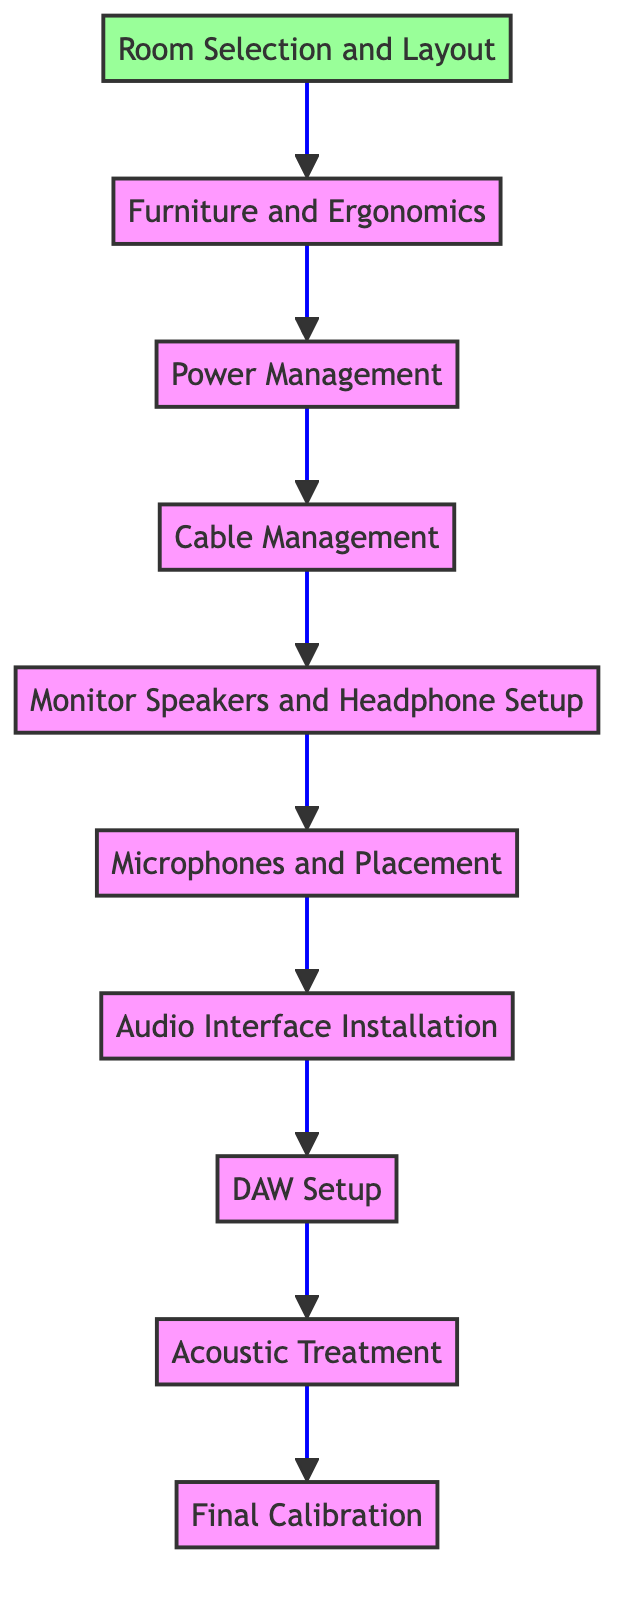What is the first step in setting up a home recording studio? The diagram indicates that the first step is "Room Selection and Layout," which is positioned at the bottom of the flow chart.
Answer: Room Selection and Layout How many nodes are in the flow chart? Counting all the elements listed in the diagram reveals there are ten nodes representing various steps in the home recording studio setup process.
Answer: Ten What follows the "Power Management" step? In the flow chart, "Cable Management" immediately follows "Power Management," indicating that it is the next step after addressing power concerns.
Answer: Cable Management Which step is directly above "Final Calibration"? The step directly above "Final Calibration" in the diagram is "Acoustic Treatment," showing the order of operations in setting up the studio.
Answer: Acoustic Treatment What is the last step in the process? The final step at the top of the flow chart is "Final Calibration," which indicates the concluding task in setting up the home recording studio.
Answer: Final Calibration How many steps are between "Monitor Speakers and Headphone Setup" and "DAW Setup"? There is one step in between "Monitor Speakers and Headphone Setup" and "DAW Setup," which is "Audio Interface Installation."
Answer: One What type of equipment is mentioned in the "Microphones and Placement" step? The step "Microphones and Placement" discusses selecting and positioning specific microphones, such as the Shure SM7B or Neumann U87, indicating the importance of microphone choice in recording.
Answer: Shure SM7B or Neumann U87 What step is completed before "DAW Setup"? Before "DAW Setup" can be completed, "Audio Interface Installation" must be finished, as per the flow of the chart.
Answer: Audio Interface Installation Which step involves arranging studio furniture? The step that involves arranging studio furniture is "Furniture and Ergonomics," which is focused on creating a comfortable and accessible recording environment.
Answer: Furniture and Ergonomics 